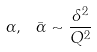<formula> <loc_0><loc_0><loc_500><loc_500>\alpha , \ \bar { \alpha } \sim \frac { { \mathit \Lambda } ^ { 2 } } { Q ^ { 2 } }</formula> 